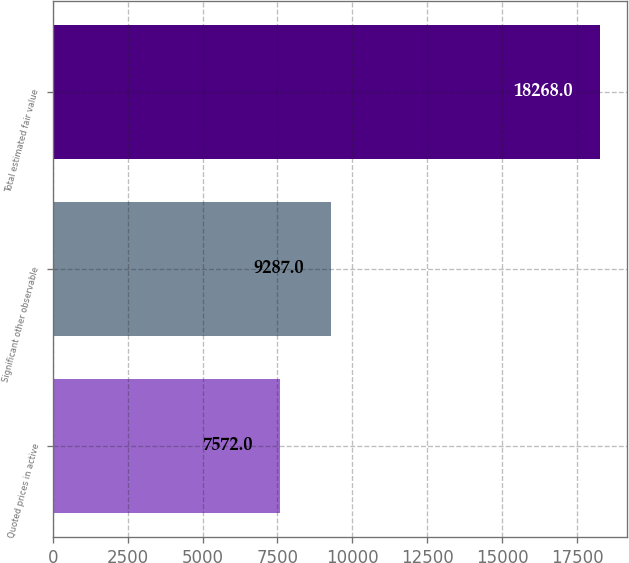<chart> <loc_0><loc_0><loc_500><loc_500><bar_chart><fcel>Quoted prices in active<fcel>Significant other observable<fcel>Total estimated fair value<nl><fcel>7572<fcel>9287<fcel>18268<nl></chart> 